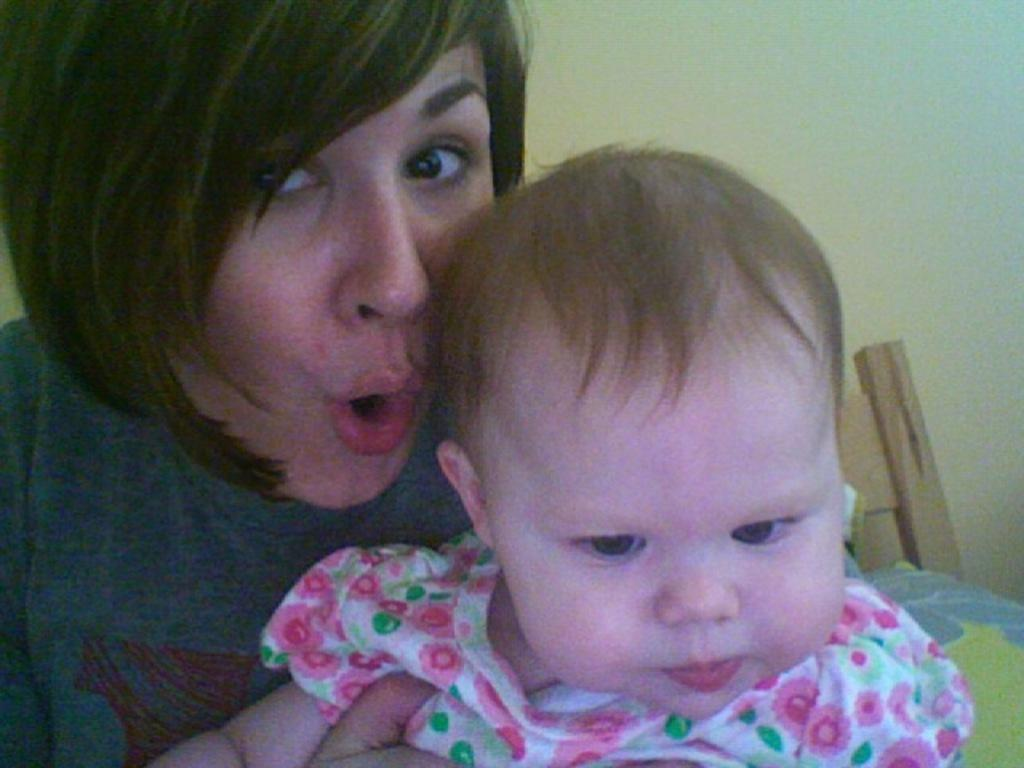Who is present in the image? There is a woman and a child in the image. What is the woman wearing? The woman is wearing a grey t-shirt. What is the child wearing? The child is wearing a white dress. What sign can be seen in the image? There is no sign present in the image. What interests does the child have, as depicted in the image? The image does not provide information about the child's interests. 